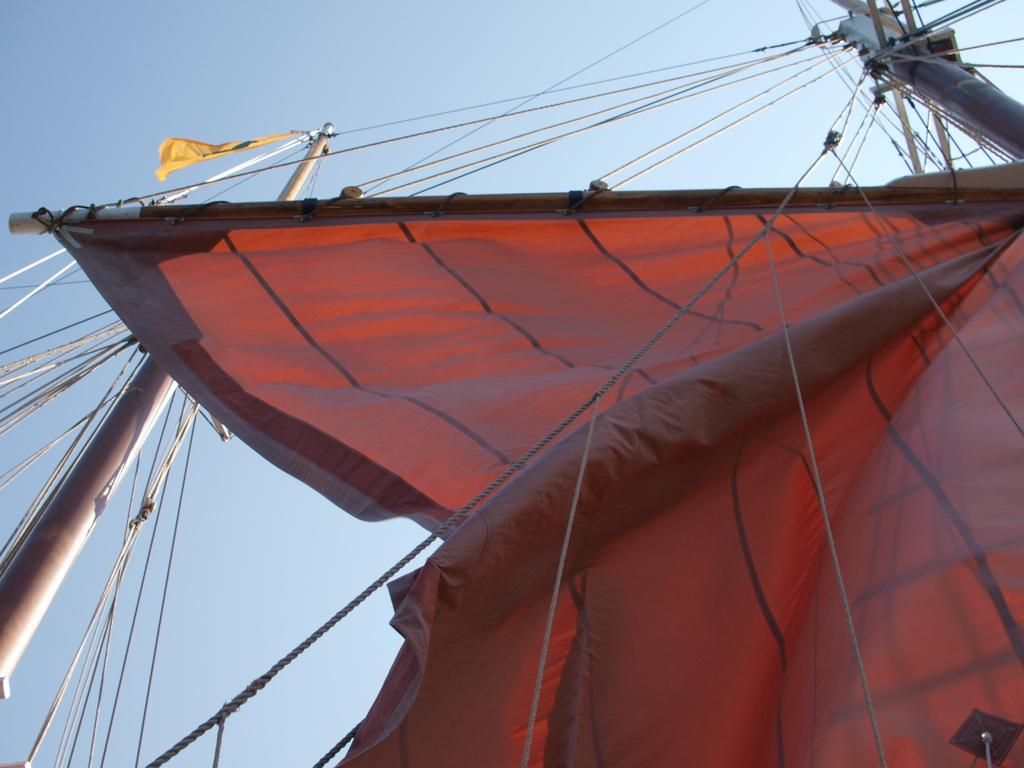What is connecting the two poles in the image? The two poles are connected with wires and ropes in the image. What type of shelter is visible in the image? There is a tent in the image. What is the condition of the sky in the image? The sky is clear in the image. What type of ornament is hanging from the poles in the image? There is no ornament hanging from the poles in the image; only wires and ropes are connecting the poles. How does the pipe contribute to the structure in the image? There is no pipe present in the image; it only features two poles connected with wires and ropes and a tent. 